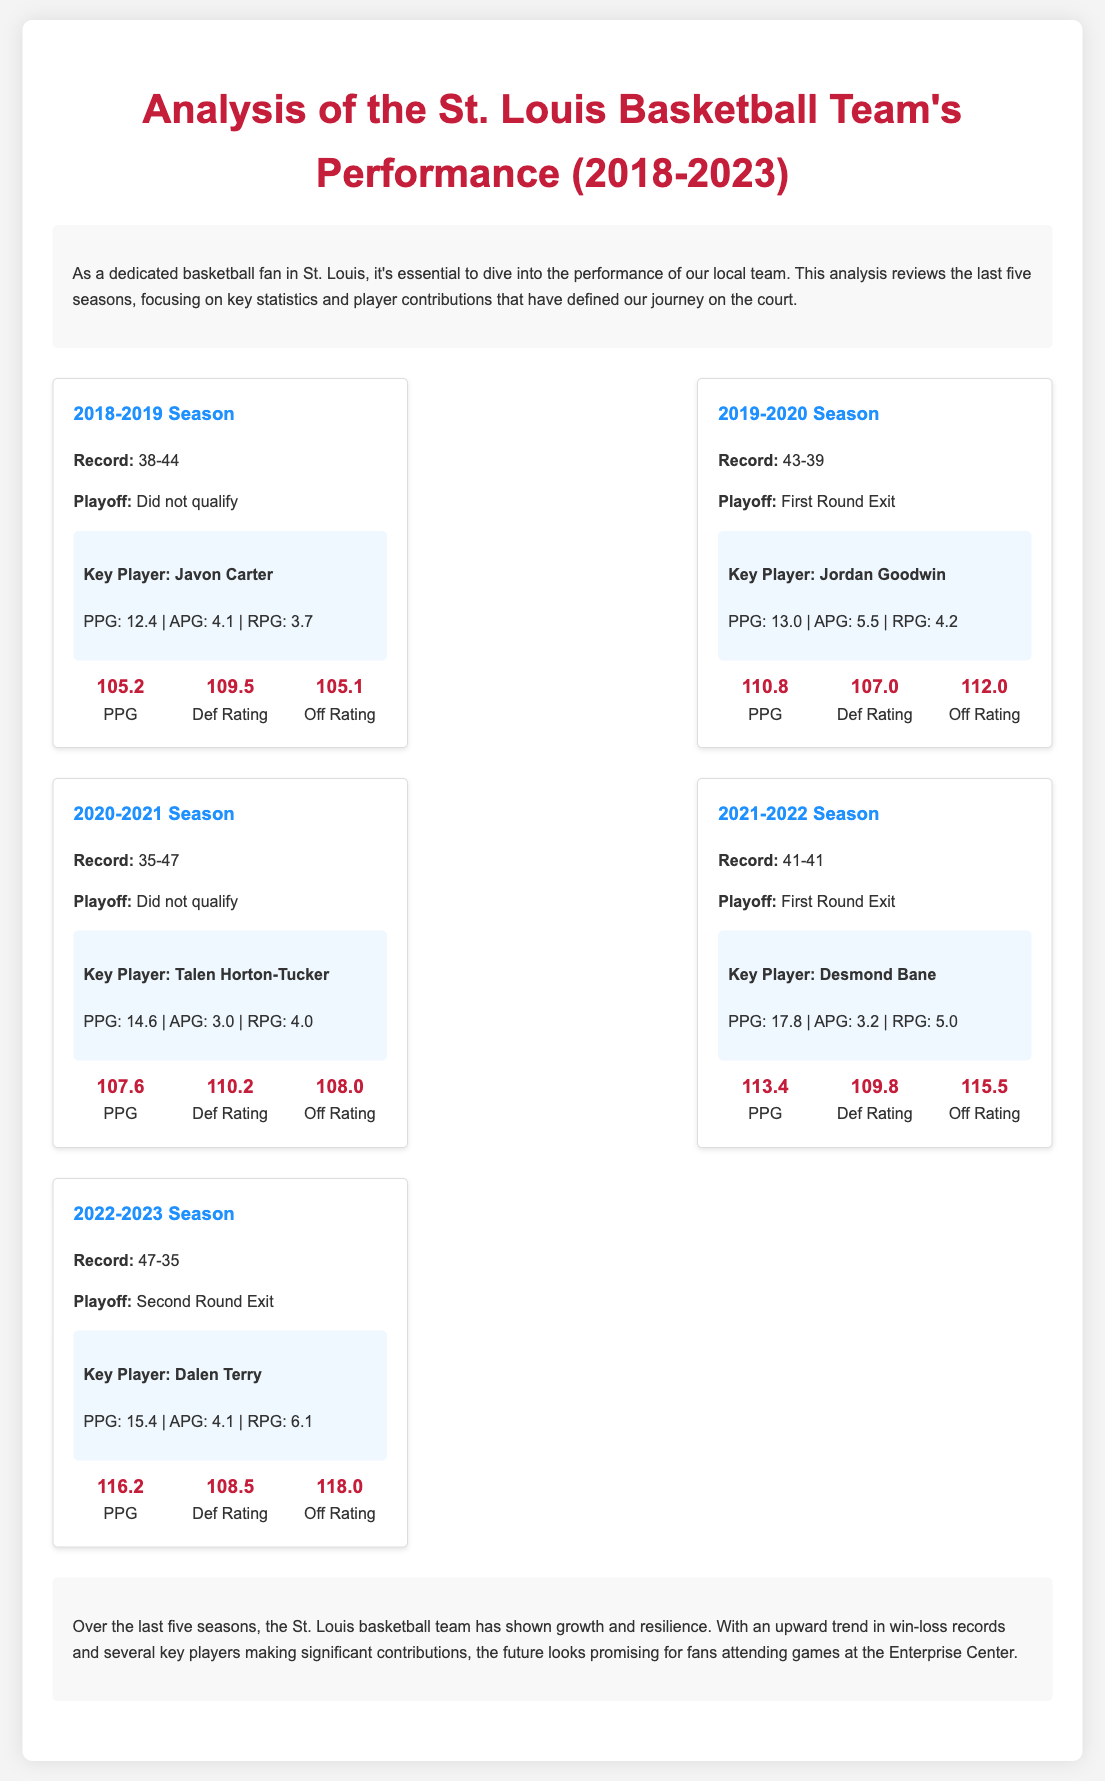What was the record of the St. Louis basketball team in the 2021-2022 season? The record is stated clearly for each season, specifically for the 2021-2022 season as 41-41.
Answer: 41-41 Who was the key player for the 2020-2021 season? The document lists a key player for each season, identifying Talen Horton-Tucker for the 2020-2021 season.
Answer: Talen Horton-Tucker How many points per game did Desmond Bane average in the 2021-2022 season? The average points per game (PPG) for Desmond Bane during that season is provided in the document, which is 17.8.
Answer: 17.8 Which season had the highest points per game (PPG)? By comparing the PPG values across all seasons, the 2022-2023 season has the highest PPG at 116.2.
Answer: 116.2 What was the team's playoff result in the 2019-2020 season? The playoff result is summarized for each season, where the 2019-2020 season resulted in a First Round Exit.
Answer: First Round Exit Which player had the highest rebounds per game (RPG) in the 2022-2023 season? The document states Dalen Terry had an RPG of 6.1, which is the highest for that season among the listed players.
Answer: Dalen Terry What was the offensive rating for the 2019-2020 season? The offensive rating (Off Rating) provided for the 2019-2020 season is listed as 112.0.
Answer: 112.0 Did the team qualify for the playoffs in the 2018-2019 season? The document explicitly states the playoff qualification status for each season, confirming that they did not qualify in 2018-2019.
Answer: Did not qualify What was the defensive rating for the 2022-2023 season? The defensive rating for the 2022-2023 season is mentioned as 108.5 in the stats section of the document.
Answer: 108.5 